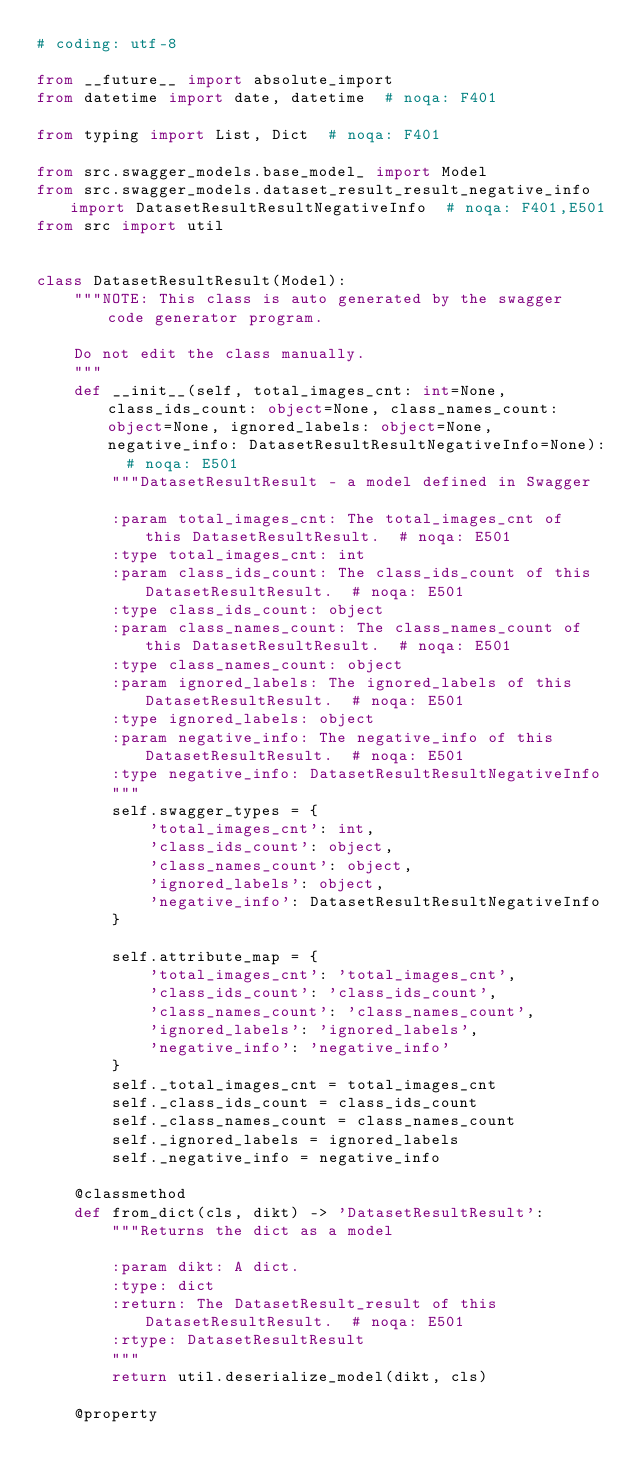<code> <loc_0><loc_0><loc_500><loc_500><_Python_># coding: utf-8

from __future__ import absolute_import
from datetime import date, datetime  # noqa: F401

from typing import List, Dict  # noqa: F401

from src.swagger_models.base_model_ import Model
from src.swagger_models.dataset_result_result_negative_info import DatasetResultResultNegativeInfo  # noqa: F401,E501
from src import util


class DatasetResultResult(Model):
    """NOTE: This class is auto generated by the swagger code generator program.

    Do not edit the class manually.
    """
    def __init__(self, total_images_cnt: int=None, class_ids_count: object=None, class_names_count: object=None, ignored_labels: object=None, negative_info: DatasetResultResultNegativeInfo=None):  # noqa: E501
        """DatasetResultResult - a model defined in Swagger

        :param total_images_cnt: The total_images_cnt of this DatasetResultResult.  # noqa: E501
        :type total_images_cnt: int
        :param class_ids_count: The class_ids_count of this DatasetResultResult.  # noqa: E501
        :type class_ids_count: object
        :param class_names_count: The class_names_count of this DatasetResultResult.  # noqa: E501
        :type class_names_count: object
        :param ignored_labels: The ignored_labels of this DatasetResultResult.  # noqa: E501
        :type ignored_labels: object
        :param negative_info: The negative_info of this DatasetResultResult.  # noqa: E501
        :type negative_info: DatasetResultResultNegativeInfo
        """
        self.swagger_types = {
            'total_images_cnt': int,
            'class_ids_count': object,
            'class_names_count': object,
            'ignored_labels': object,
            'negative_info': DatasetResultResultNegativeInfo
        }

        self.attribute_map = {
            'total_images_cnt': 'total_images_cnt',
            'class_ids_count': 'class_ids_count',
            'class_names_count': 'class_names_count',
            'ignored_labels': 'ignored_labels',
            'negative_info': 'negative_info'
        }
        self._total_images_cnt = total_images_cnt
        self._class_ids_count = class_ids_count
        self._class_names_count = class_names_count
        self._ignored_labels = ignored_labels
        self._negative_info = negative_info

    @classmethod
    def from_dict(cls, dikt) -> 'DatasetResultResult':
        """Returns the dict as a model

        :param dikt: A dict.
        :type: dict
        :return: The DatasetResult_result of this DatasetResultResult.  # noqa: E501
        :rtype: DatasetResultResult
        """
        return util.deserialize_model(dikt, cls)

    @property</code> 